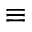<formula> <loc_0><loc_0><loc_500><loc_500>\equiv</formula> 